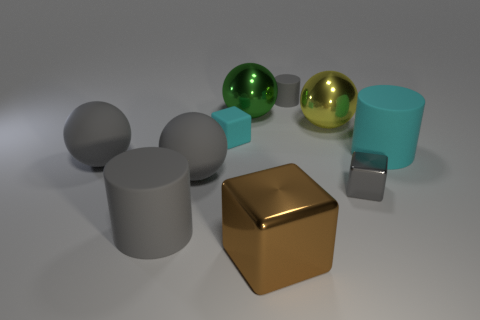There is a metal thing that is in front of the large cyan cylinder and to the left of the gray cube; what is its shape?
Give a very brief answer. Cube. What color is the matte cylinder to the right of the cube that is on the right side of the big metallic thing that is in front of the large cyan rubber object?
Your answer should be very brief. Cyan. Are there more big brown shiny objects right of the yellow shiny object than cyan rubber blocks that are in front of the brown shiny cube?
Provide a succinct answer. No. How many other objects are the same size as the cyan rubber cylinder?
Keep it short and to the point. 6. What size is the other rubber cylinder that is the same color as the tiny matte cylinder?
Ensure brevity in your answer.  Large. The gray thing behind the cyan thing that is to the right of the small metallic block is made of what material?
Your response must be concise. Rubber. Are there any large matte cylinders behind the big brown block?
Offer a terse response. Yes. Are there more gray metal objects that are on the left side of the small gray rubber cylinder than large gray matte spheres?
Your answer should be compact. No. Are there any other small rubber cylinders of the same color as the small matte cylinder?
Make the answer very short. No. The metal object that is the same size as the matte block is what color?
Offer a terse response. Gray. 